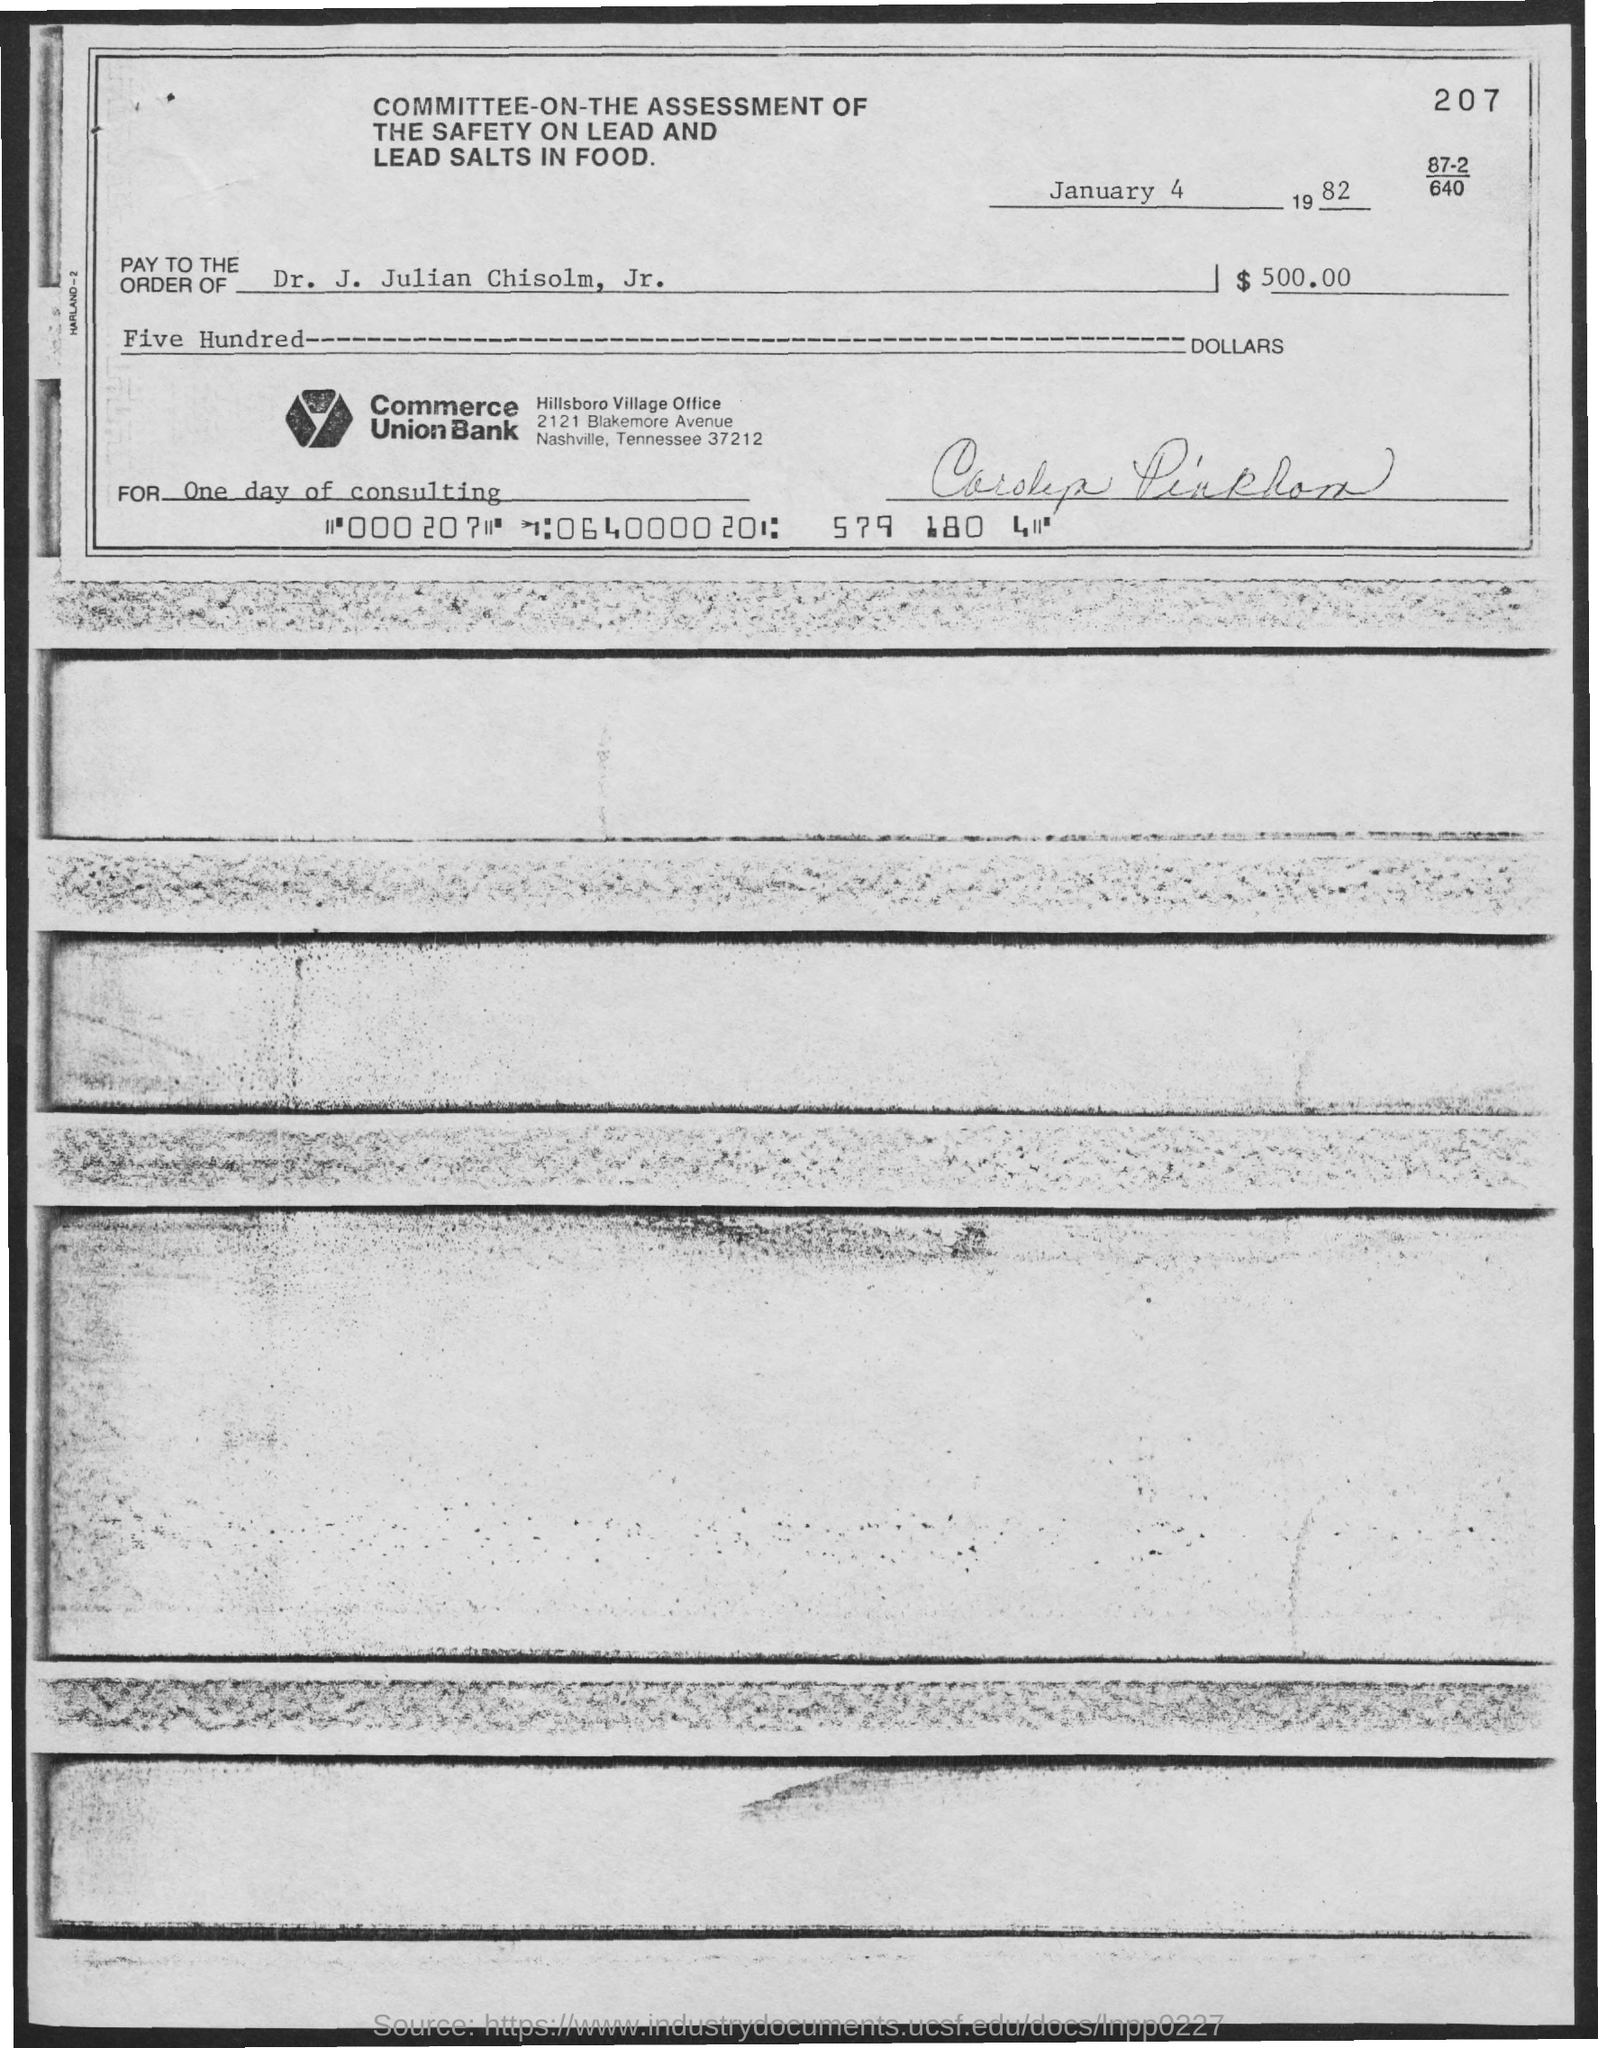What is the bank name?
Provide a succinct answer. Commerce union bank. To whom is the payment?
Keep it short and to the point. Dr. J. Julian Chisolm, Jr. How much is the amount?
Offer a very short reply. $500.00. What is the date?
Your answer should be very brief. January 4 1982. 